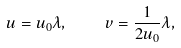<formula> <loc_0><loc_0><loc_500><loc_500>u = u _ { 0 } \lambda , \quad v = \frac { 1 } { 2 u _ { 0 } } \lambda ,</formula> 